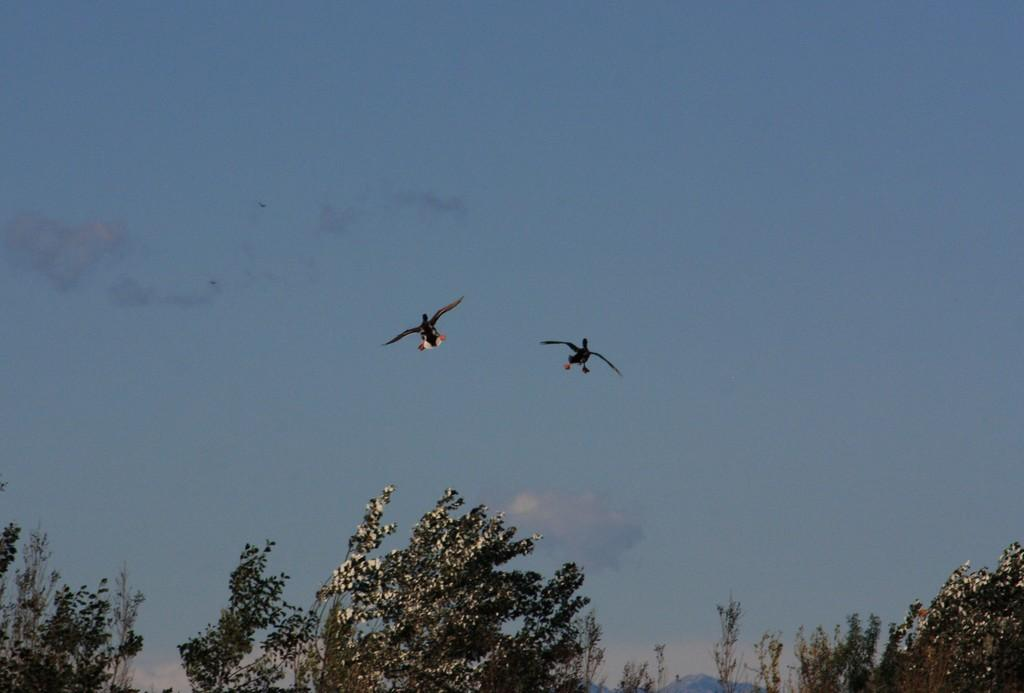What animals can be seen in the image? There are two birds flying in the air. What type of vegetation is at the bottom of the image? There are trees at the bottom of the image. What geographical feature is behind the trees? There is a hill behind the trees. What is visible at the top of the image? The sky is visible at the top of the image. How many people are in the crowd at the bottom of the image? There is no crowd present in the image; it features two birds flying in the air, trees, a hill, and the sky. What type of tree is depicted in the image? The image does not depict a specific type of tree; it simply shows trees at the bottom of the image. 